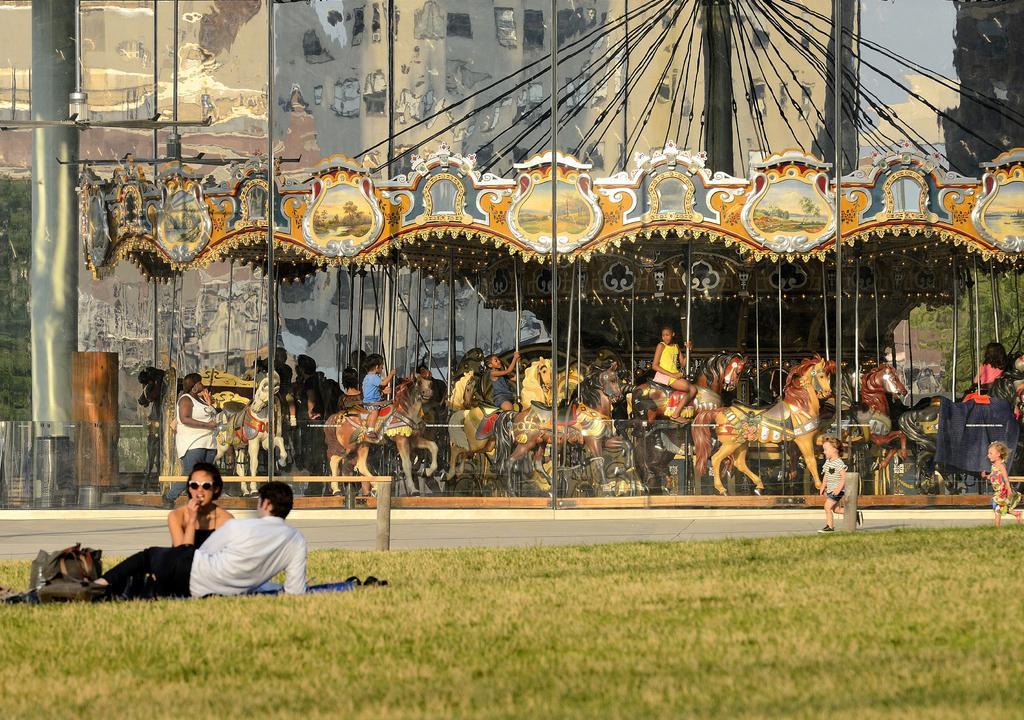Can you describe this image briefly? This looks like an exhibition. There are some children, who are playing. There are toy horses. There is grass at the bottom. Two persons are sitting in that grass. One is a woman, other one is a man. There is a bag on the left side. 